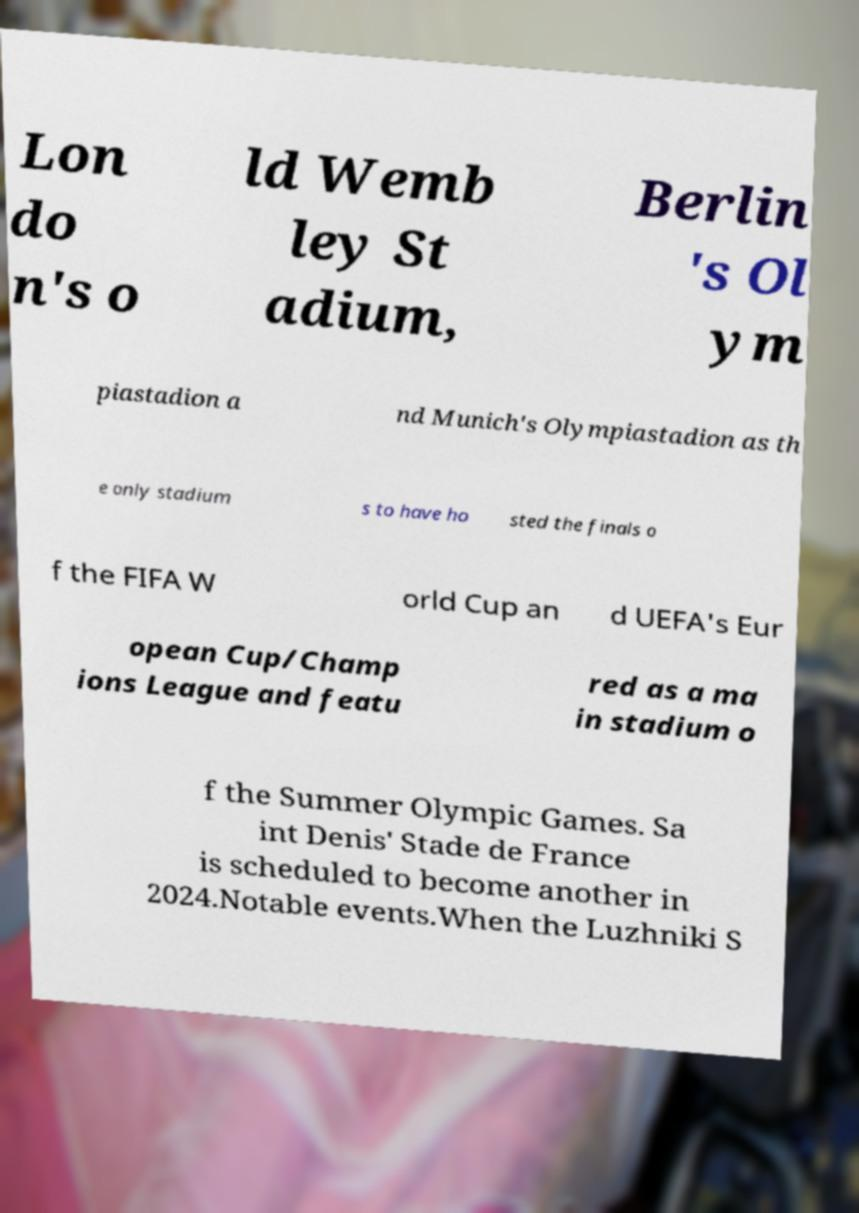What messages or text are displayed in this image? I need them in a readable, typed format. Lon do n's o ld Wemb ley St adium, Berlin 's Ol ym piastadion a nd Munich's Olympiastadion as th e only stadium s to have ho sted the finals o f the FIFA W orld Cup an d UEFA's Eur opean Cup/Champ ions League and featu red as a ma in stadium o f the Summer Olympic Games. Sa int Denis' Stade de France is scheduled to become another in 2024.Notable events.When the Luzhniki S 